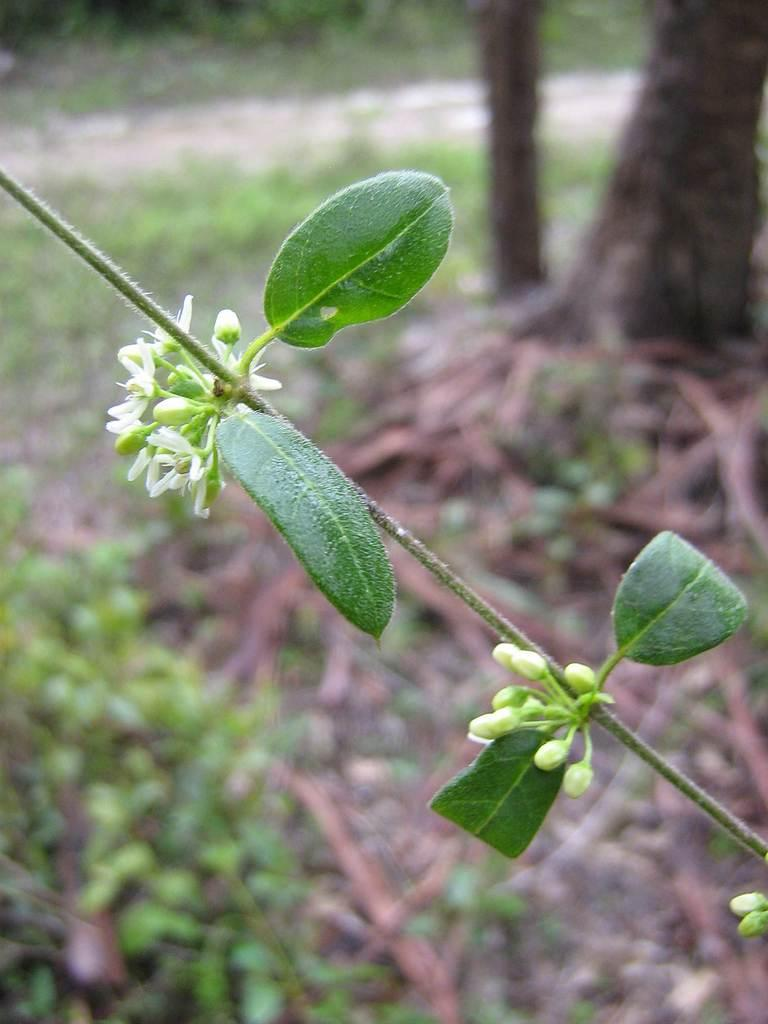What type of vegetation can be seen in the image? There are leaves and flowers in the image. Can you describe the background of the image? The background of the image is blurred. What type of wrench is being used to lift the weight in the image? There is no wrench or weight present in the image; it features leaves and flowers with a blurred background. 